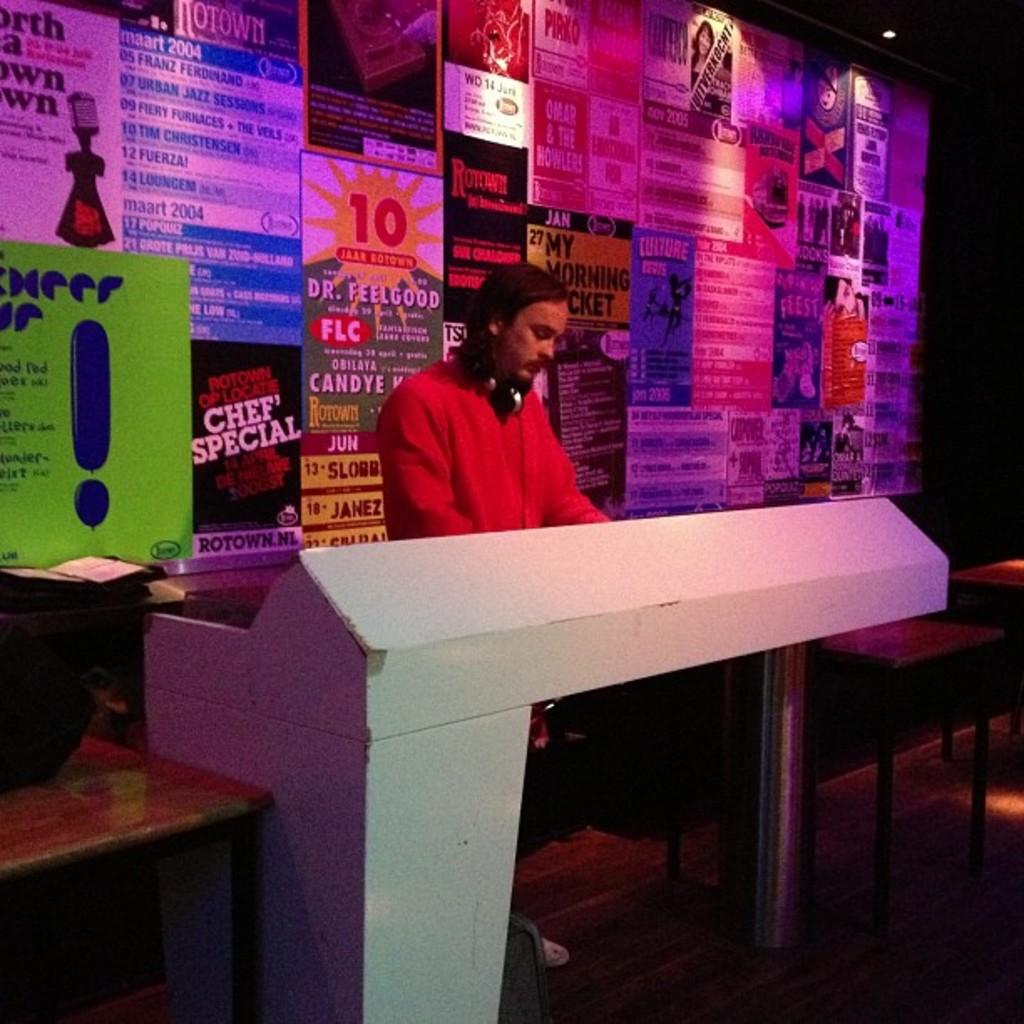What number is in red?
Ensure brevity in your answer.  10. Can the red posters be made more readable?
Your answer should be compact. Yes. 